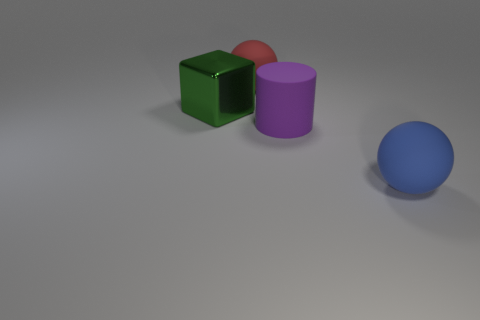Add 4 blue balls. How many objects exist? 8 Subtract all cylinders. How many objects are left? 3 Add 2 big purple cylinders. How many big purple cylinders exist? 3 Subtract 1 green blocks. How many objects are left? 3 Subtract all big green blocks. Subtract all red matte blocks. How many objects are left? 3 Add 2 big blue matte objects. How many big blue matte objects are left? 3 